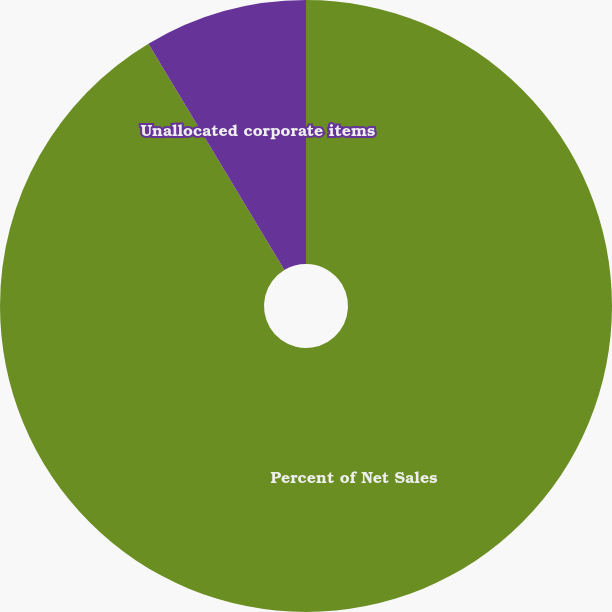Convert chart. <chart><loc_0><loc_0><loc_500><loc_500><pie_chart><fcel>Percent of Net Sales<fcel>Unallocated corporate items<nl><fcel>91.39%<fcel>8.61%<nl></chart> 